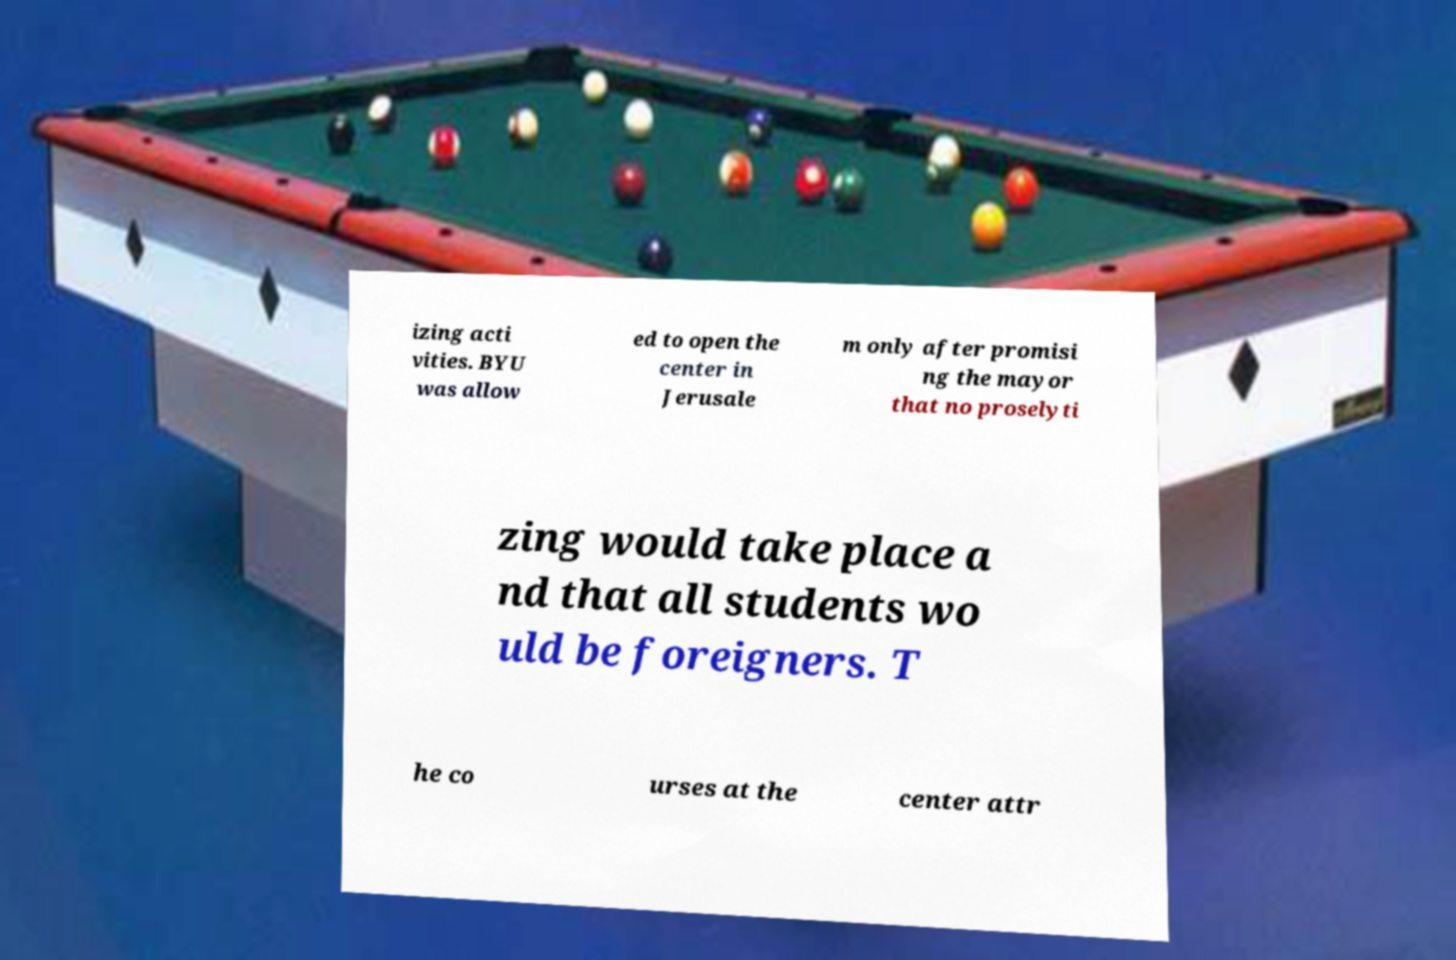Please read and relay the text visible in this image. What does it say? izing acti vities. BYU was allow ed to open the center in Jerusale m only after promisi ng the mayor that no proselyti zing would take place a nd that all students wo uld be foreigners. T he co urses at the center attr 